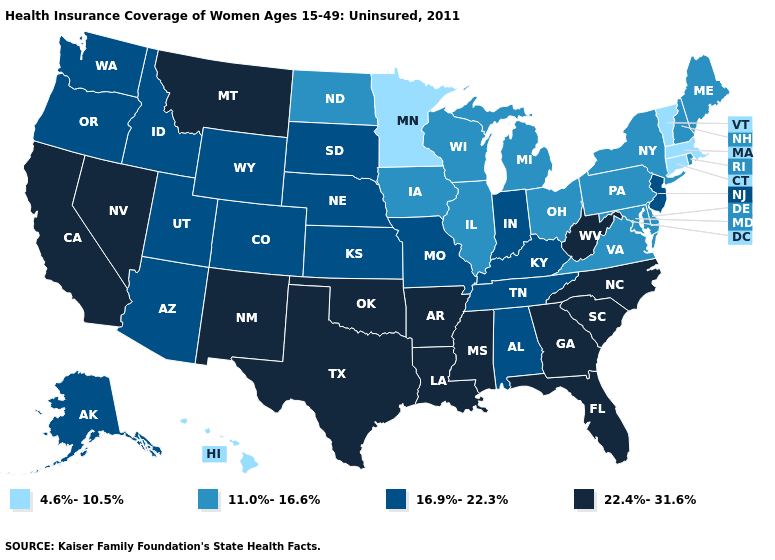Name the states that have a value in the range 16.9%-22.3%?
Quick response, please. Alabama, Alaska, Arizona, Colorado, Idaho, Indiana, Kansas, Kentucky, Missouri, Nebraska, New Jersey, Oregon, South Dakota, Tennessee, Utah, Washington, Wyoming. What is the value of New Hampshire?
Answer briefly. 11.0%-16.6%. Does the map have missing data?
Be succinct. No. What is the value of Oregon?
Quick response, please. 16.9%-22.3%. Among the states that border Maryland , which have the highest value?
Keep it brief. West Virginia. Name the states that have a value in the range 16.9%-22.3%?
Write a very short answer. Alabama, Alaska, Arizona, Colorado, Idaho, Indiana, Kansas, Kentucky, Missouri, Nebraska, New Jersey, Oregon, South Dakota, Tennessee, Utah, Washington, Wyoming. Does Iowa have the lowest value in the USA?
Be succinct. No. What is the value of California?
Be succinct. 22.4%-31.6%. What is the value of Connecticut?
Short answer required. 4.6%-10.5%. Name the states that have a value in the range 16.9%-22.3%?
Keep it brief. Alabama, Alaska, Arizona, Colorado, Idaho, Indiana, Kansas, Kentucky, Missouri, Nebraska, New Jersey, Oregon, South Dakota, Tennessee, Utah, Washington, Wyoming. What is the value of Rhode Island?
Short answer required. 11.0%-16.6%. Which states have the lowest value in the USA?
Answer briefly. Connecticut, Hawaii, Massachusetts, Minnesota, Vermont. How many symbols are there in the legend?
Give a very brief answer. 4. Does Connecticut have the lowest value in the Northeast?
Give a very brief answer. Yes. 